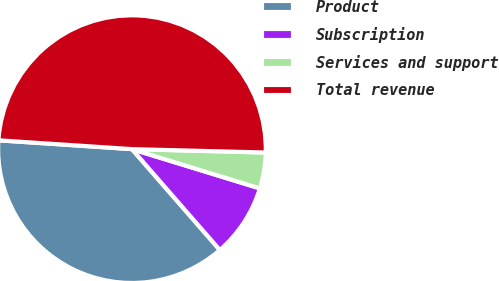Convert chart to OTSL. <chart><loc_0><loc_0><loc_500><loc_500><pie_chart><fcel>Product<fcel>Subscription<fcel>Services and support<fcel>Total revenue<nl><fcel>37.46%<fcel>8.85%<fcel>4.34%<fcel>49.35%<nl></chart> 